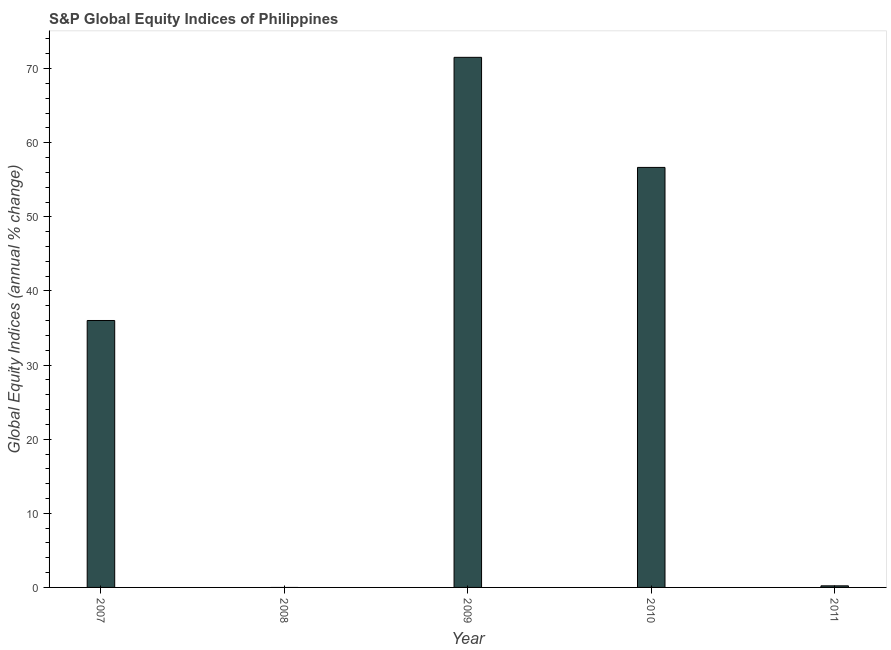Does the graph contain any zero values?
Keep it short and to the point. Yes. What is the title of the graph?
Ensure brevity in your answer.  S&P Global Equity Indices of Philippines. What is the label or title of the Y-axis?
Ensure brevity in your answer.  Global Equity Indices (annual % change). What is the s&p global equity indices in 2009?
Make the answer very short. 71.52. Across all years, what is the maximum s&p global equity indices?
Give a very brief answer. 71.52. Across all years, what is the minimum s&p global equity indices?
Ensure brevity in your answer.  0. In which year was the s&p global equity indices maximum?
Ensure brevity in your answer.  2009. What is the sum of the s&p global equity indices?
Your answer should be compact. 164.42. What is the difference between the s&p global equity indices in 2009 and 2010?
Your response must be concise. 14.85. What is the average s&p global equity indices per year?
Ensure brevity in your answer.  32.88. What is the median s&p global equity indices?
Offer a terse response. 36.02. In how many years, is the s&p global equity indices greater than 64 %?
Your answer should be very brief. 1. What is the ratio of the s&p global equity indices in 2010 to that in 2011?
Give a very brief answer. 263.48. Is the s&p global equity indices in 2007 less than that in 2009?
Your answer should be compact. Yes. What is the difference between the highest and the second highest s&p global equity indices?
Offer a terse response. 14.85. Is the sum of the s&p global equity indices in 2009 and 2011 greater than the maximum s&p global equity indices across all years?
Your response must be concise. Yes. What is the difference between the highest and the lowest s&p global equity indices?
Offer a very short reply. 71.52. In how many years, is the s&p global equity indices greater than the average s&p global equity indices taken over all years?
Your answer should be very brief. 3. Are all the bars in the graph horizontal?
Provide a succinct answer. No. What is the Global Equity Indices (annual % change) in 2007?
Your answer should be compact. 36.02. What is the Global Equity Indices (annual % change) in 2009?
Your answer should be compact. 71.52. What is the Global Equity Indices (annual % change) of 2010?
Make the answer very short. 56.67. What is the Global Equity Indices (annual % change) in 2011?
Keep it short and to the point. 0.22. What is the difference between the Global Equity Indices (annual % change) in 2007 and 2009?
Offer a very short reply. -35.51. What is the difference between the Global Equity Indices (annual % change) in 2007 and 2010?
Your answer should be compact. -20.65. What is the difference between the Global Equity Indices (annual % change) in 2007 and 2011?
Keep it short and to the point. 35.8. What is the difference between the Global Equity Indices (annual % change) in 2009 and 2010?
Your answer should be compact. 14.85. What is the difference between the Global Equity Indices (annual % change) in 2009 and 2011?
Offer a terse response. 71.31. What is the difference between the Global Equity Indices (annual % change) in 2010 and 2011?
Your answer should be very brief. 56.45. What is the ratio of the Global Equity Indices (annual % change) in 2007 to that in 2009?
Offer a very short reply. 0.5. What is the ratio of the Global Equity Indices (annual % change) in 2007 to that in 2010?
Your answer should be very brief. 0.64. What is the ratio of the Global Equity Indices (annual % change) in 2007 to that in 2011?
Provide a short and direct response. 167.45. What is the ratio of the Global Equity Indices (annual % change) in 2009 to that in 2010?
Your answer should be compact. 1.26. What is the ratio of the Global Equity Indices (annual % change) in 2009 to that in 2011?
Make the answer very short. 332.53. What is the ratio of the Global Equity Indices (annual % change) in 2010 to that in 2011?
Your answer should be very brief. 263.48. 